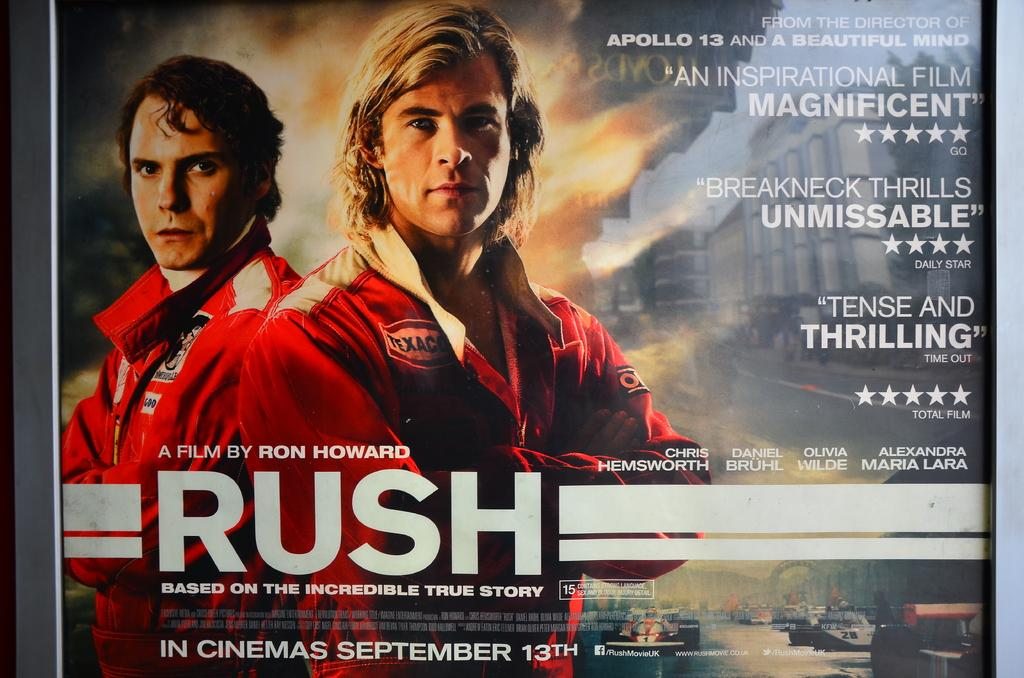<image>
Summarize the visual content of the image. A poster for Ron Howard's film, Rush, states it opens September 13th. 